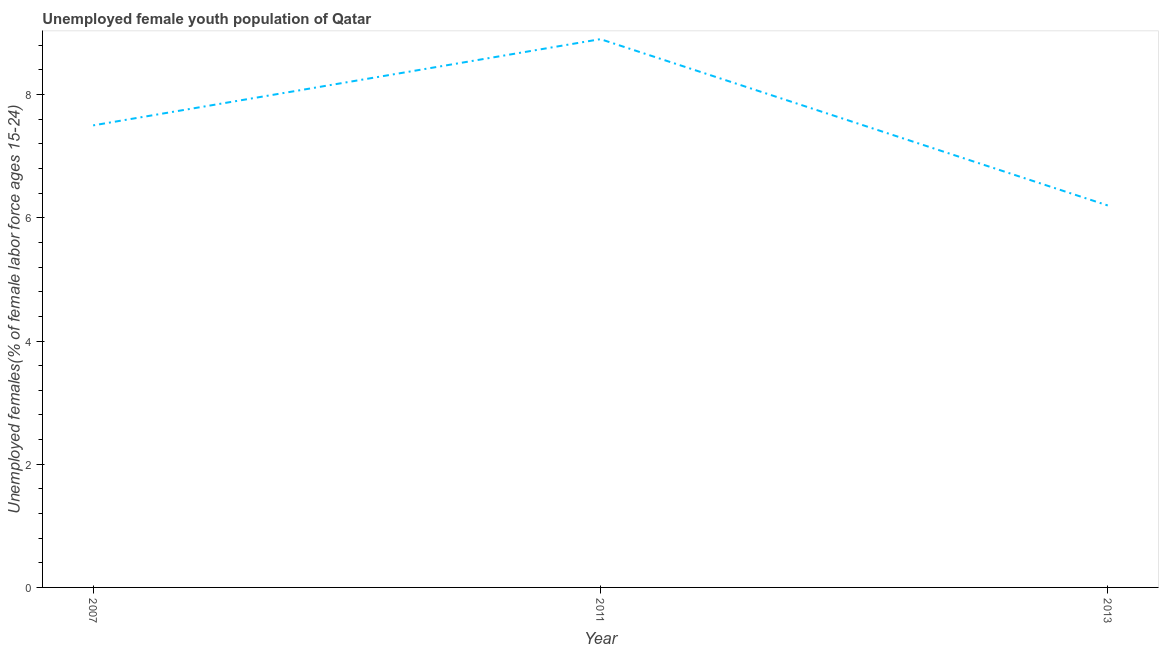What is the unemployed female youth in 2013?
Your response must be concise. 6.2. Across all years, what is the maximum unemployed female youth?
Offer a terse response. 8.9. Across all years, what is the minimum unemployed female youth?
Make the answer very short. 6.2. In which year was the unemployed female youth maximum?
Your response must be concise. 2011. What is the sum of the unemployed female youth?
Give a very brief answer. 22.6. What is the difference between the unemployed female youth in 2011 and 2013?
Your response must be concise. 2.7. What is the average unemployed female youth per year?
Provide a short and direct response. 7.53. In how many years, is the unemployed female youth greater than 8.4 %?
Ensure brevity in your answer.  1. What is the ratio of the unemployed female youth in 2007 to that in 2013?
Offer a terse response. 1.21. Is the difference between the unemployed female youth in 2007 and 2011 greater than the difference between any two years?
Make the answer very short. No. What is the difference between the highest and the second highest unemployed female youth?
Provide a short and direct response. 1.4. What is the difference between the highest and the lowest unemployed female youth?
Ensure brevity in your answer.  2.7. Does the unemployed female youth monotonically increase over the years?
Provide a succinct answer. No. Does the graph contain grids?
Provide a short and direct response. No. What is the title of the graph?
Provide a succinct answer. Unemployed female youth population of Qatar. What is the label or title of the X-axis?
Keep it short and to the point. Year. What is the label or title of the Y-axis?
Provide a succinct answer. Unemployed females(% of female labor force ages 15-24). What is the Unemployed females(% of female labor force ages 15-24) of 2011?
Your answer should be very brief. 8.9. What is the Unemployed females(% of female labor force ages 15-24) in 2013?
Keep it short and to the point. 6.2. What is the difference between the Unemployed females(% of female labor force ages 15-24) in 2007 and 2011?
Your response must be concise. -1.4. What is the difference between the Unemployed females(% of female labor force ages 15-24) in 2007 and 2013?
Keep it short and to the point. 1.3. What is the ratio of the Unemployed females(% of female labor force ages 15-24) in 2007 to that in 2011?
Ensure brevity in your answer.  0.84. What is the ratio of the Unemployed females(% of female labor force ages 15-24) in 2007 to that in 2013?
Your response must be concise. 1.21. What is the ratio of the Unemployed females(% of female labor force ages 15-24) in 2011 to that in 2013?
Ensure brevity in your answer.  1.44. 